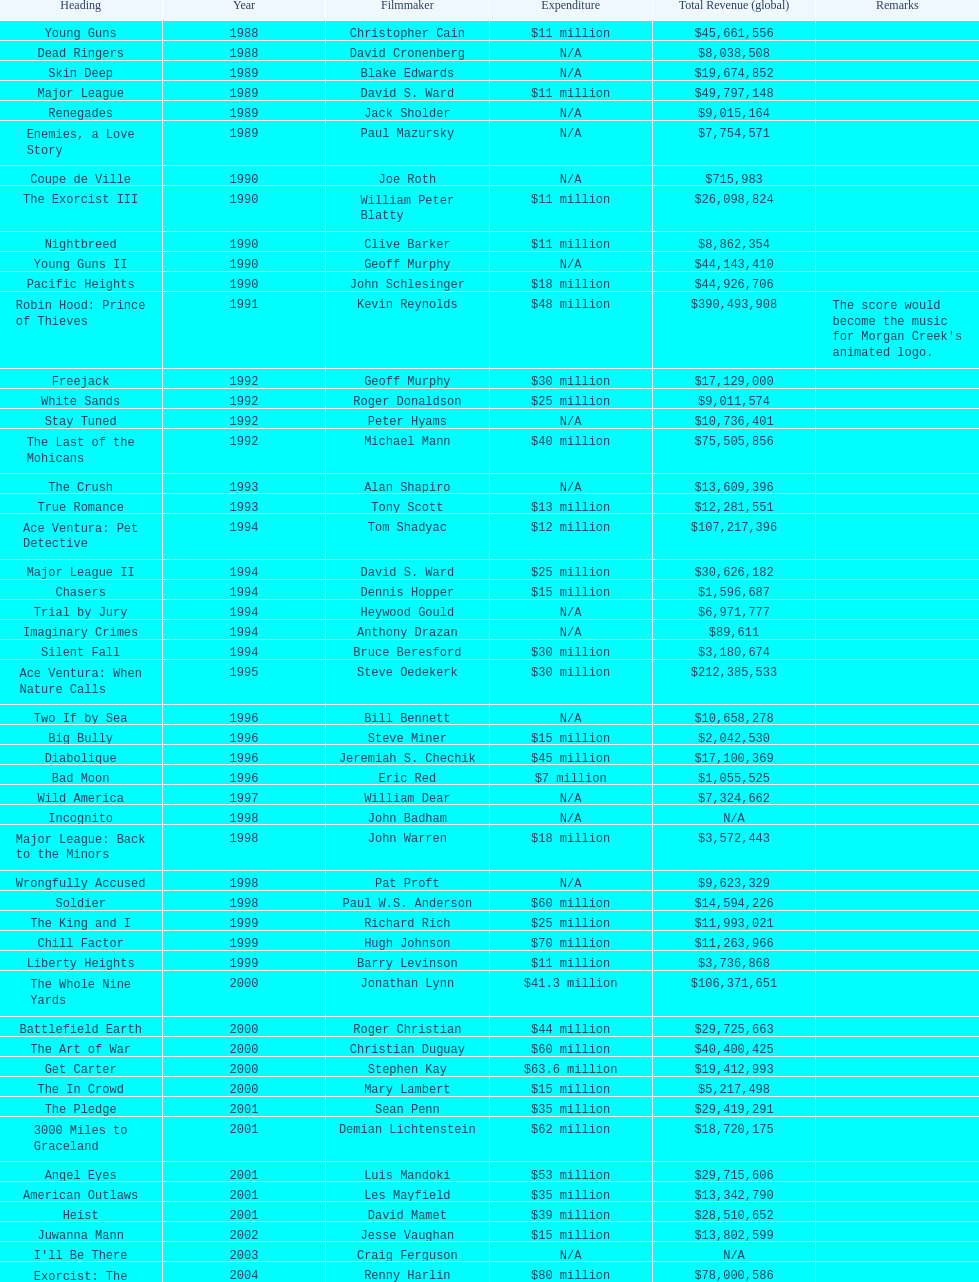Was true romance's box office earnings more or less than that of diabolique? Less. 